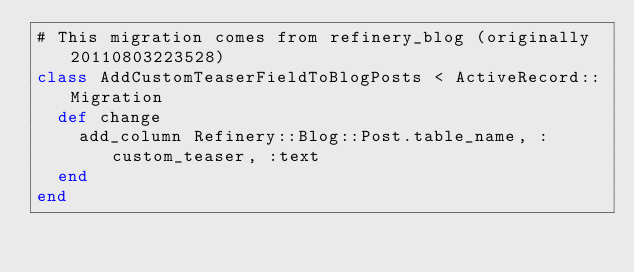Convert code to text. <code><loc_0><loc_0><loc_500><loc_500><_Ruby_># This migration comes from refinery_blog (originally 20110803223528)
class AddCustomTeaserFieldToBlogPosts < ActiveRecord::Migration
  def change
    add_column Refinery::Blog::Post.table_name, :custom_teaser, :text
  end
end

</code> 